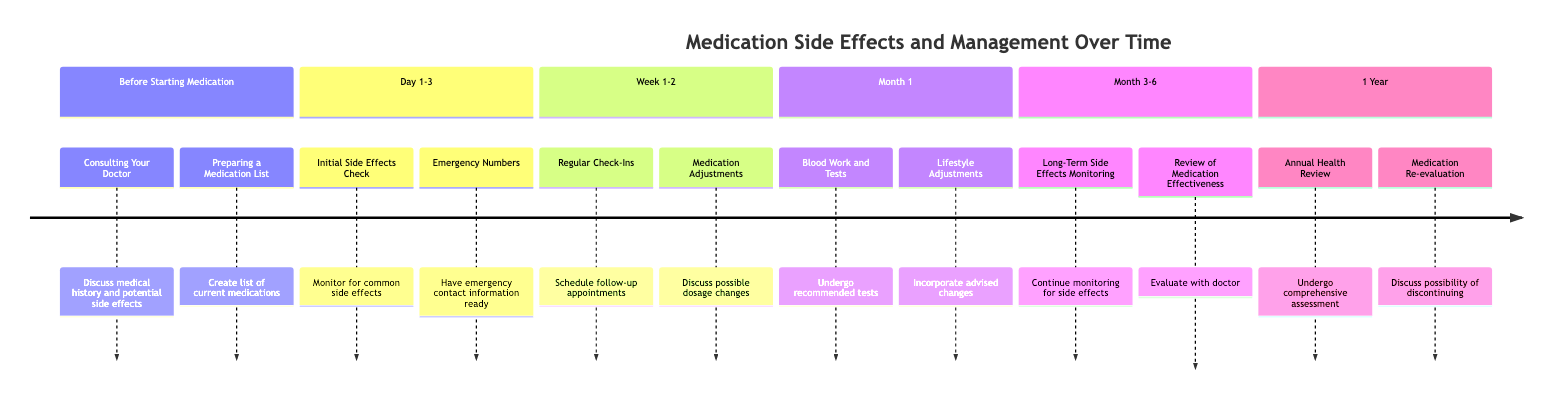What is the first action to take before starting medication? The diagram states that the first action is "Consulting Your Doctor." This refers to the initial step where you discuss your medical history with your doctor.
Answer: Consulting Your Doctor How many weeks are covered in the timeline for monitoring side effects? The timeline specifies "Week 1-2," which indicates a two-week period for monitoring side effects, following the initial days after starting medication.
Answer: 2 What is a task to be completed in Month 1? The timeline mentions two significant tasks, one of which is "Blood Work and Tests." This suggests that during the first month, a health check, including blood tests, should be performed.
Answer: Blood Work and Tests What should you do during Day 1-3 if you experience side effects? According to the diagram, during Day 1-3, you should conduct an "Initial Side Effects Check," which implies that you should actively monitor your side effects.
Answer: Initial Side Effects Check What evaluation occurs at the one-year mark? The timeline notes that an "Annual Health Review" happens at the one-year mark, implying that a comprehensive assessment of health and medications is undertaken.
Answer: Annual Health Review If side effects are severe, what should you discuss with your doctor in Week 1-2? The diagram advises discussing "Medication Adjustments," implying that if you encounter severe side effects, it is essential to talk about changing the dosage or medication.
Answer: Medication Adjustments How many major timepoints are identified in the timeline? The timeline has six major timepoints, indicating the steps in medication management spanning from before starting medication to one year after.
Answer: 6 What is suggested for managing lifestyle changes in Month 1? The diagram mentions "Lifestyle Adjustments," indicating that during the first month, you should incorporate any lifestyle changes recommended to help ease side effects.
Answer: Lifestyle Adjustments 